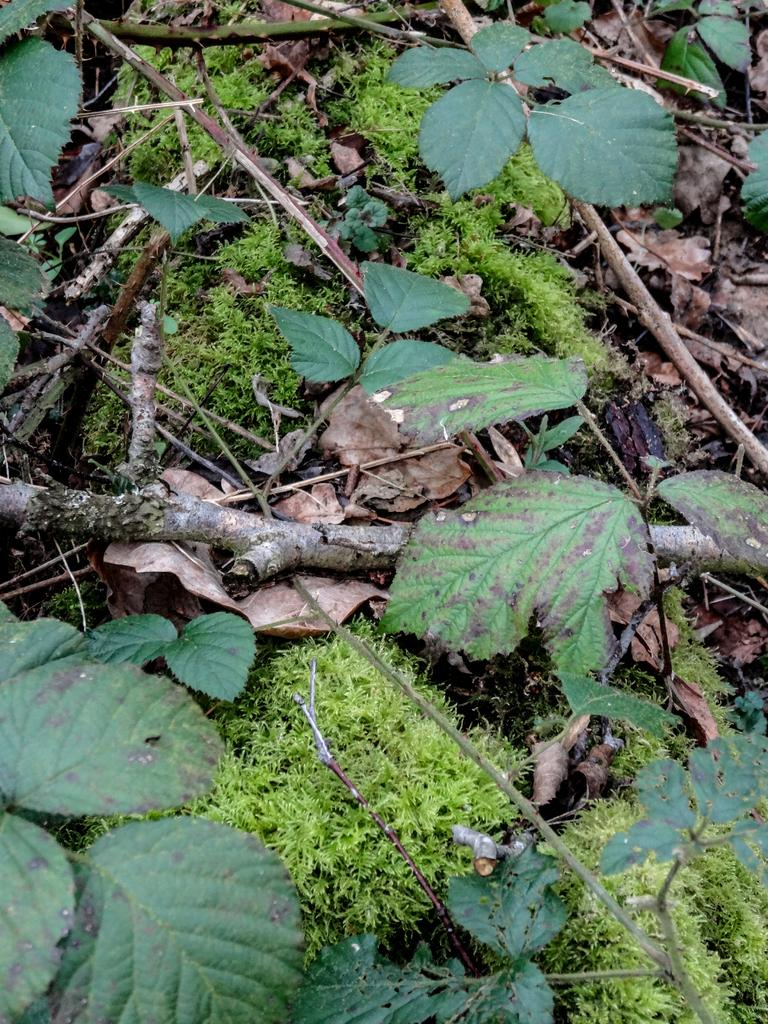What type of vegetation can be seen in the image? There are green leaves and branches in the image. What is the ground covered with in the image? There is grass in the image. Where is the office located in the image? There is no office present in the image; it features green leaves, branches, and grass. What type of advertisement can be seen on the patch in the image? There is no patch or advertisement present in the image. 